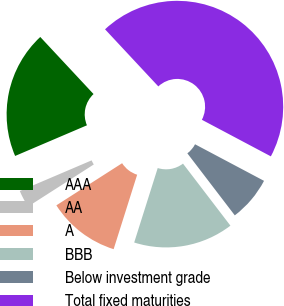Convert chart. <chart><loc_0><loc_0><loc_500><loc_500><pie_chart><fcel>AAA<fcel>AA<fcel>A<fcel>BBB<fcel>Below investment grade<fcel>Total fixed maturities<nl><fcel>19.47%<fcel>2.65%<fcel>11.06%<fcel>15.26%<fcel>6.85%<fcel>44.71%<nl></chart> 